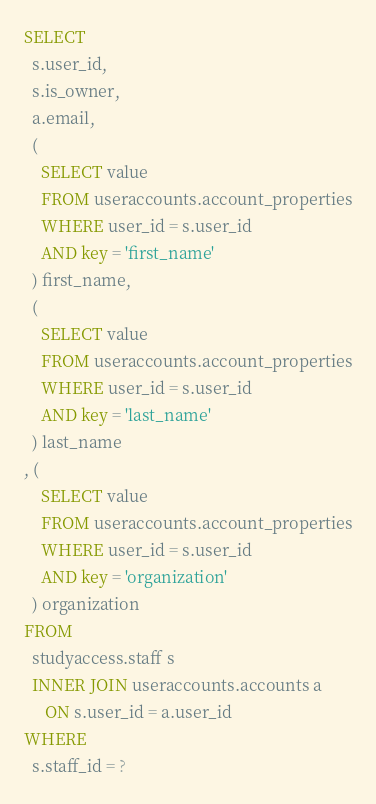Convert code to text. <code><loc_0><loc_0><loc_500><loc_500><_SQL_>SELECT
  s.user_id,
  s.is_owner,
  a.email,
  (
    SELECT value
    FROM useraccounts.account_properties
    WHERE user_id = s.user_id
    AND key = 'first_name'
  ) first_name,
  (
    SELECT value
    FROM useraccounts.account_properties
    WHERE user_id = s.user_id
    AND key = 'last_name'
  ) last_name
, (
    SELECT value
    FROM useraccounts.account_properties
    WHERE user_id = s.user_id
    AND key = 'organization'
  ) organization
FROM
  studyaccess.staff s
  INNER JOIN useraccounts.accounts a
     ON s.user_id = a.user_id
WHERE
  s.staff_id = ?
</code> 